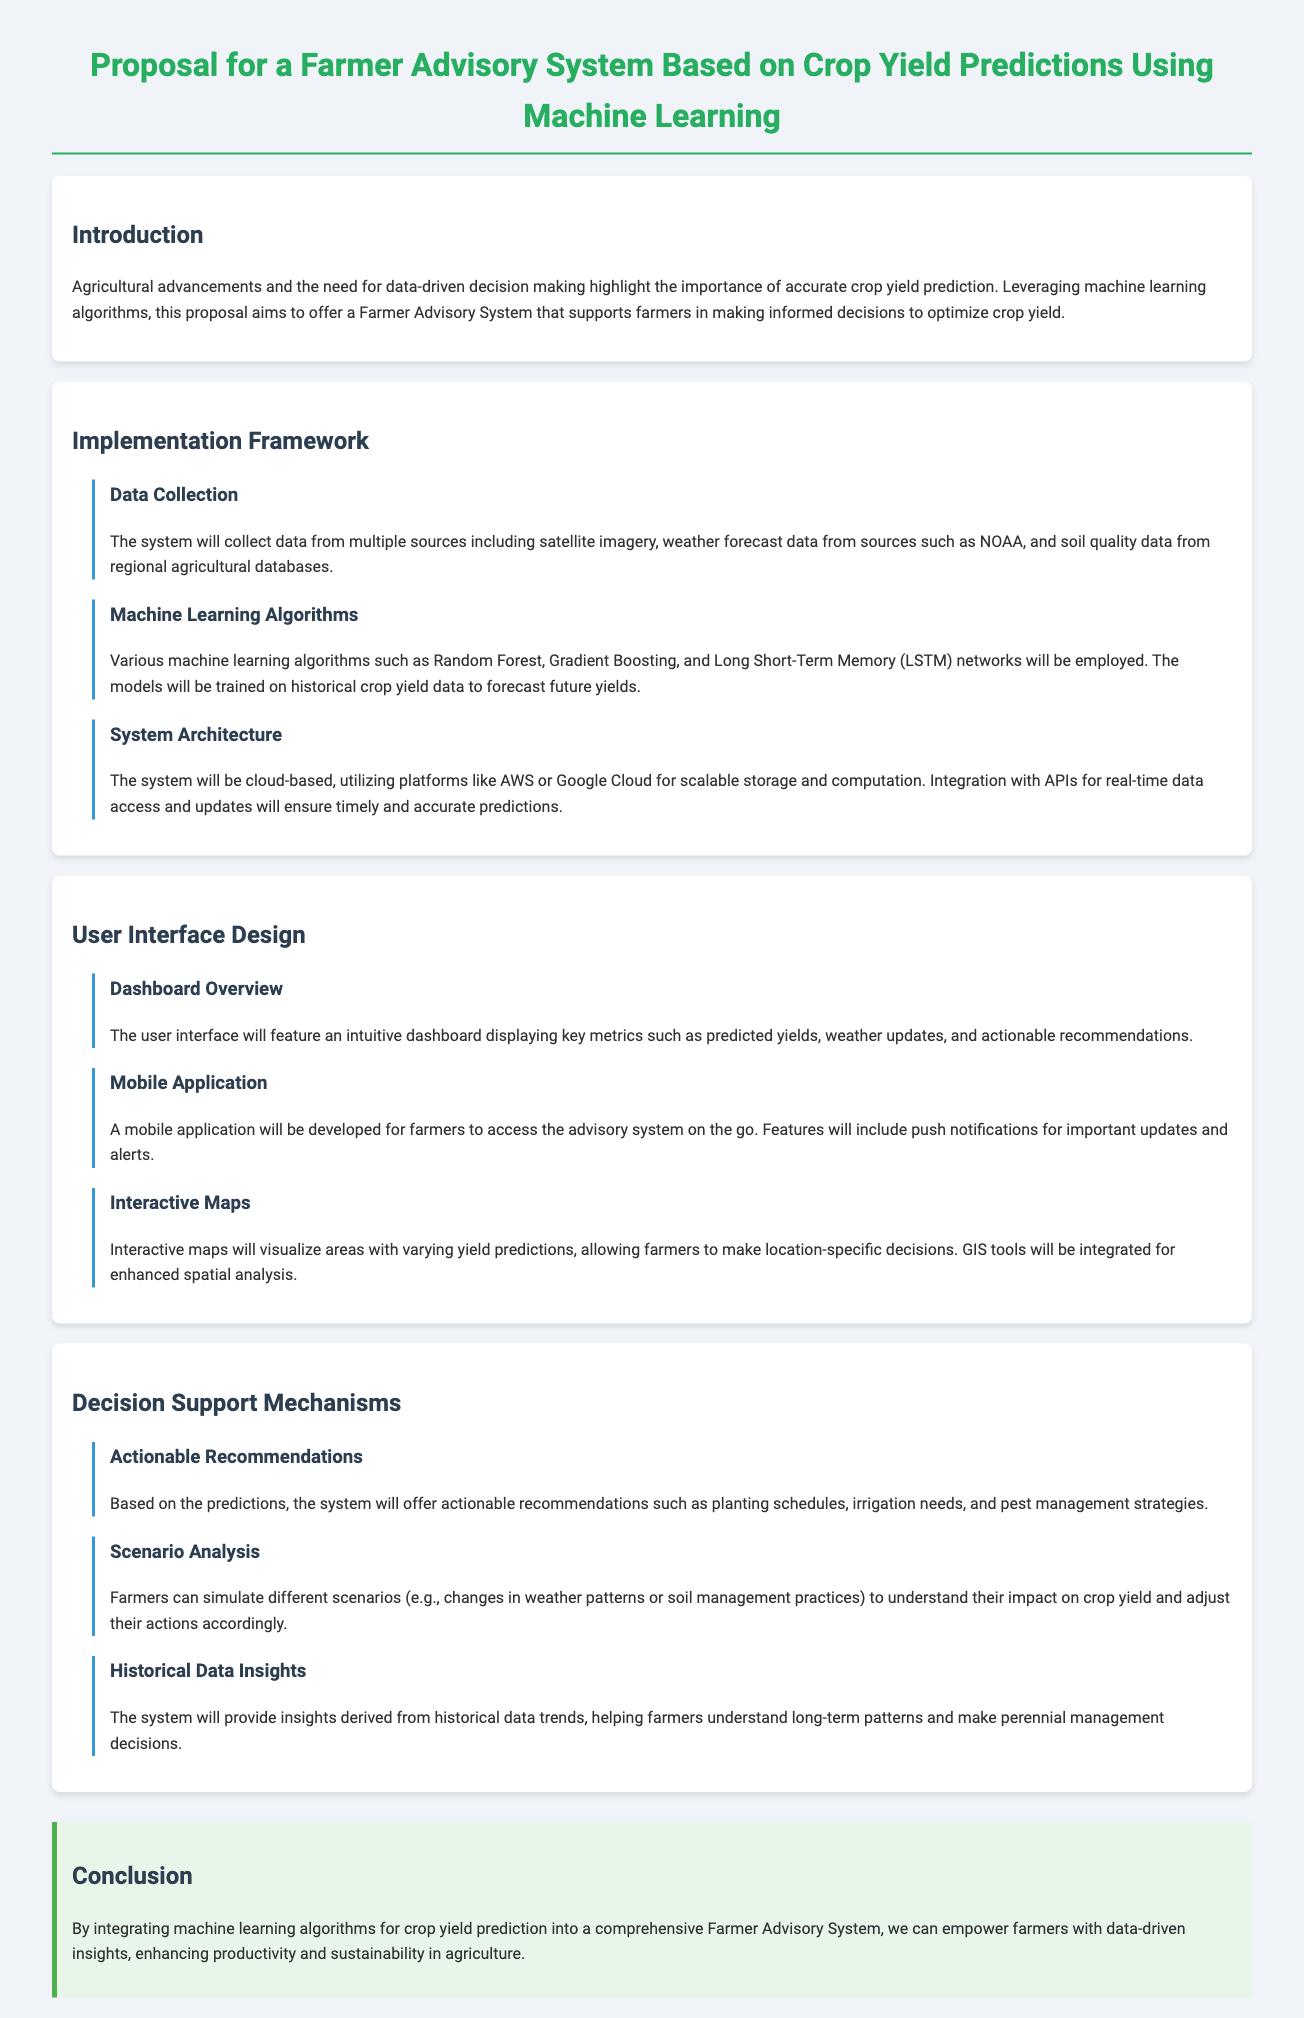What is the main purpose of the proposal? The proposal aims to offer a Farmer Advisory System that supports farmers in making informed decisions to optimize crop yield.
Answer: optimize crop yield Which machine learning algorithms are proposed for crop yield predictions? The document mentions several machine learning algorithms that will be employed for predictions.
Answer: Random Forest, Gradient Boosting, LSTM What type of data sources will the system collect? The proposal outlines the data sources that will be collected by the system.
Answer: satellite imagery, weather forecast data, soil quality data What key feature will the mobile application provide? The mobile application developed for farmers will have specific functionalities as listed in the document.
Answer: push notifications What mechanisms will the system use to support decision-making? The document describes various methods that will be employed for providing support to farmers.
Answer: actionable recommendations, scenario analysis, historical data insights What is a key component of the user interface? Key elements of the user interface are highlighted in the proposal, focusing on user experience.
Answer: intuitive dashboard How will the system enhance spatial analysis? The proposal discusses tools that will integrate to improve analysis related to spatial components.
Answer: GIS tools What type of analysis can farmers conduct using the system? The document specifies the types of analyses that can be performed by the farmers.
Answer: scenario analysis What is the conclusion regarding the impact of the system on agriculture? The conclusion summarizes the overall benefits of the proposed system in agriculture.
Answer: enhancing productivity and sustainability 